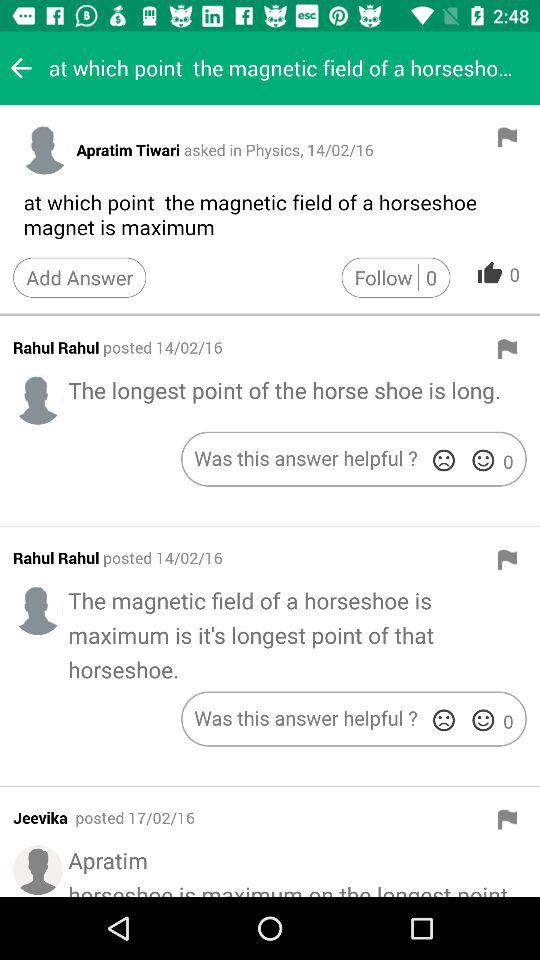On Apratim Tiwari's question, how many likes did he get? Apratim Tiwari's question got 0 likes. 